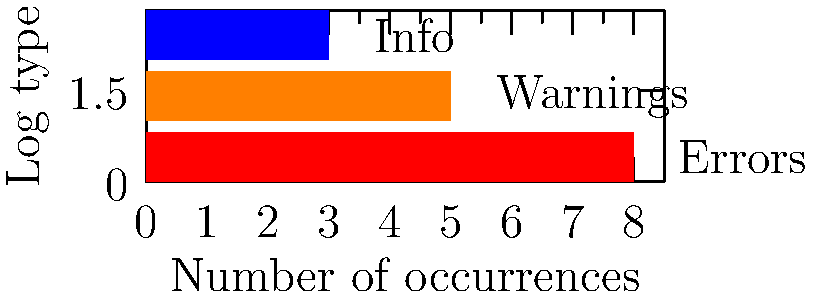Based on the error log visualization for a Linux application, which type of log entries should be addressed first to improve the software's stability? To determine which type of log entries should be addressed first to improve the software's stability, we need to analyze the information presented in the graph:

1. The graph shows three types of log entries: Errors, Warnings, and Info.
2. Each bar represents the number of occurrences for each log type.
3. Errors (red bar) have the highest number of occurrences, with 8 entries.
4. Warnings (orange bar) have 5 occurrences.
5. Info (blue bar) have the least number of occurrences, with 3 entries.

In software development and quality assurance, errors are typically considered the most critical issues that need immediate attention. They often indicate serious problems that can affect the stability, functionality, or security of the application.

Warnings are less severe than errors but still require attention, as they may lead to potential issues or suboptimal performance.

Info entries are usually informational and don't typically indicate problems that need immediate attention.

Given this hierarchy of importance (Errors > Warnings > Info) and the fact that Errors have the highest number of occurrences in the log, addressing the Error entries first would have the most significant impact on improving the software's stability.
Answer: Errors 